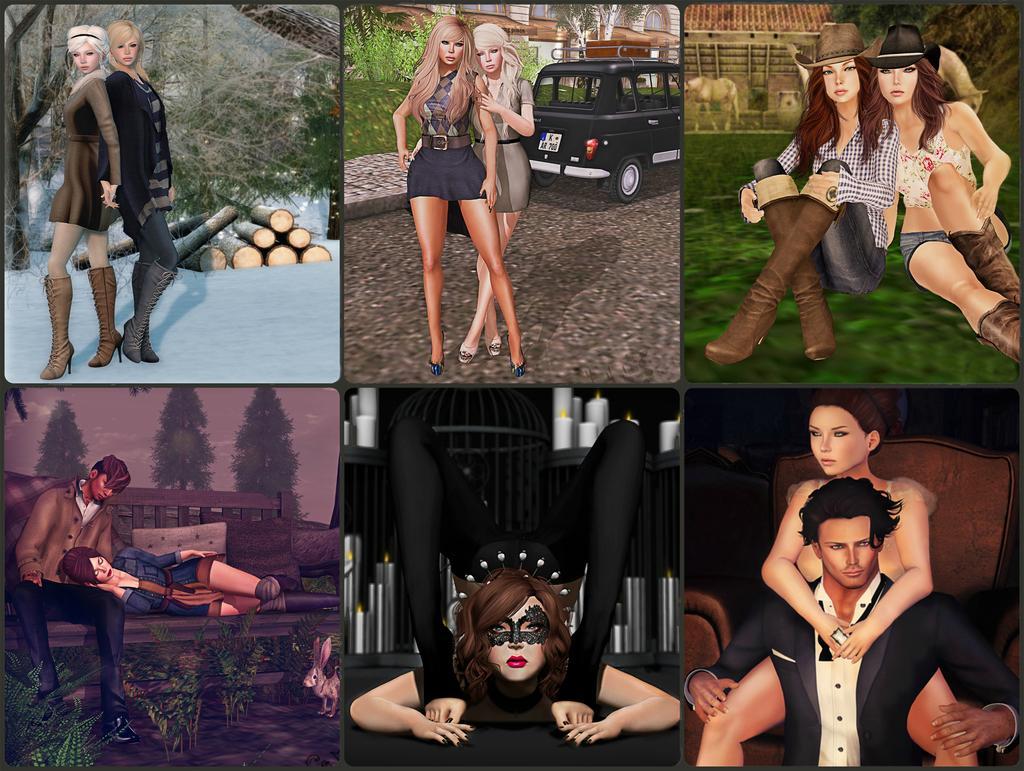Please provide a concise description of this image. In this picture we can see animated collage frames. On the top there are two women who are sitting on the grass. Behind them we can see horse under the hut. Here we can see two women who are standing on the road, behind them car. Here we can see grass and building. On the top left there are two women was standing on the snow. Here we can see trees and plants. On the bottom there is a man who is a sitting on the bench and a woman who is lying on his leg. On the bottom right there are two person sitting on the chair. Here we can see a woman who is wearing black dress. 